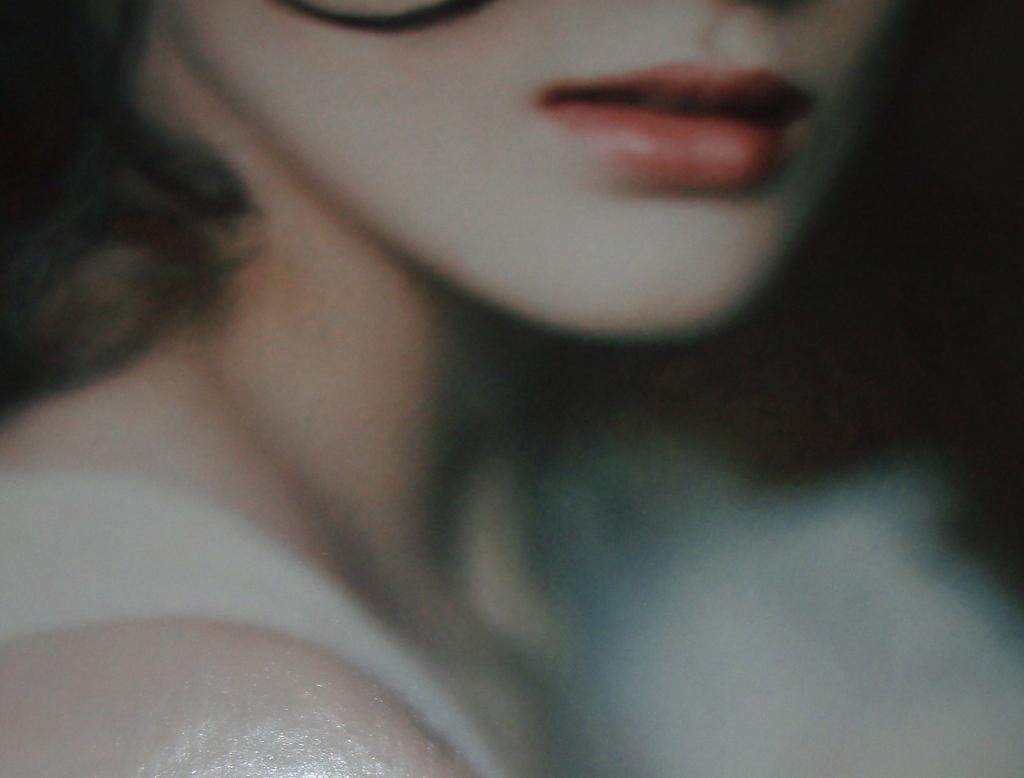Could you give a brief overview of what you see in this image? In this image there is a woman. 